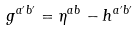<formula> <loc_0><loc_0><loc_500><loc_500>g ^ { a ^ { \prime } b ^ { \prime } } = \eta ^ { a b } - h ^ { a ^ { \prime } b ^ { \prime } }</formula> 